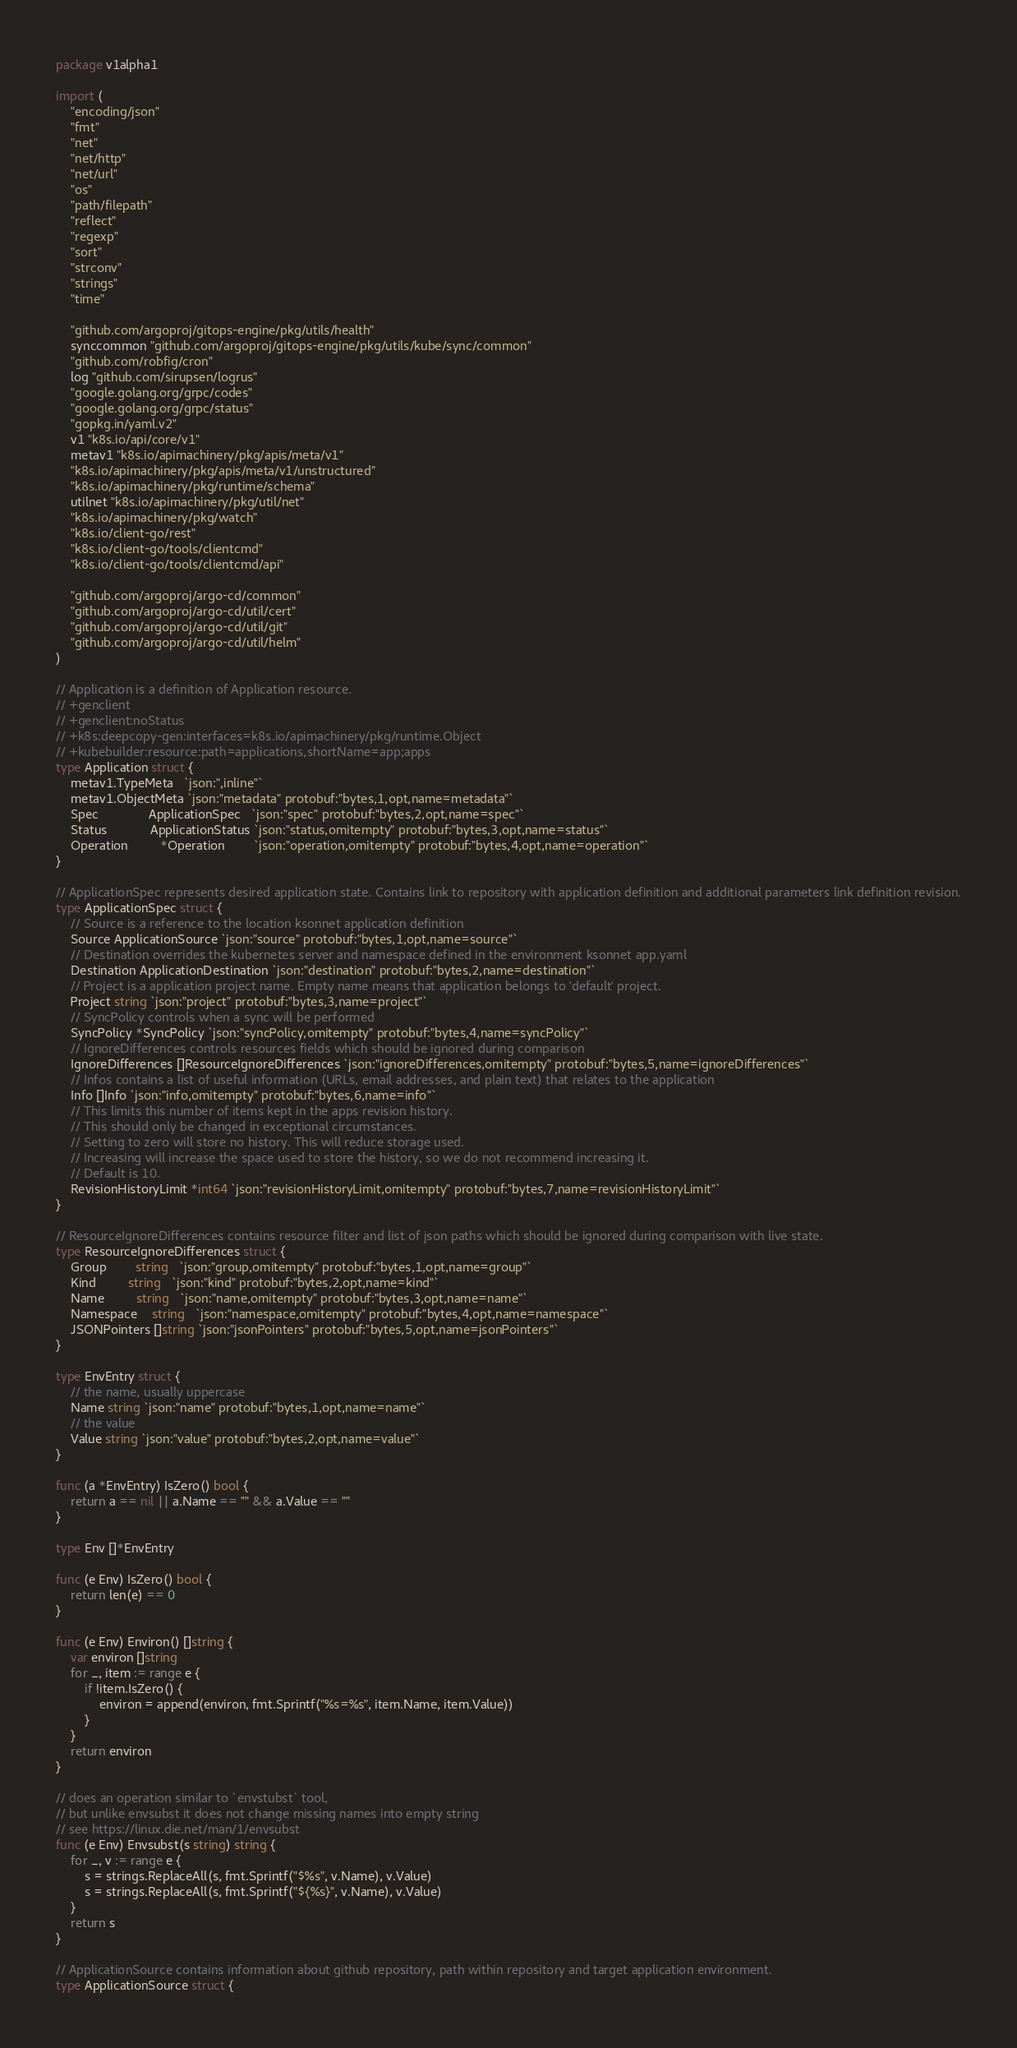<code> <loc_0><loc_0><loc_500><loc_500><_Go_>package v1alpha1

import (
	"encoding/json"
	"fmt"
	"net"
	"net/http"
	"net/url"
	"os"
	"path/filepath"
	"reflect"
	"regexp"
	"sort"
	"strconv"
	"strings"
	"time"

	"github.com/argoproj/gitops-engine/pkg/utils/health"
	synccommon "github.com/argoproj/gitops-engine/pkg/utils/kube/sync/common"
	"github.com/robfig/cron"
	log "github.com/sirupsen/logrus"
	"google.golang.org/grpc/codes"
	"google.golang.org/grpc/status"
	"gopkg.in/yaml.v2"
	v1 "k8s.io/api/core/v1"
	metav1 "k8s.io/apimachinery/pkg/apis/meta/v1"
	"k8s.io/apimachinery/pkg/apis/meta/v1/unstructured"
	"k8s.io/apimachinery/pkg/runtime/schema"
	utilnet "k8s.io/apimachinery/pkg/util/net"
	"k8s.io/apimachinery/pkg/watch"
	"k8s.io/client-go/rest"
	"k8s.io/client-go/tools/clientcmd"
	"k8s.io/client-go/tools/clientcmd/api"

	"github.com/argoproj/argo-cd/common"
	"github.com/argoproj/argo-cd/util/cert"
	"github.com/argoproj/argo-cd/util/git"
	"github.com/argoproj/argo-cd/util/helm"
)

// Application is a definition of Application resource.
// +genclient
// +genclient:noStatus
// +k8s:deepcopy-gen:interfaces=k8s.io/apimachinery/pkg/runtime.Object
// +kubebuilder:resource:path=applications,shortName=app;apps
type Application struct {
	metav1.TypeMeta   `json:",inline"`
	metav1.ObjectMeta `json:"metadata" protobuf:"bytes,1,opt,name=metadata"`
	Spec              ApplicationSpec   `json:"spec" protobuf:"bytes,2,opt,name=spec"`
	Status            ApplicationStatus `json:"status,omitempty" protobuf:"bytes,3,opt,name=status"`
	Operation         *Operation        `json:"operation,omitempty" protobuf:"bytes,4,opt,name=operation"`
}

// ApplicationSpec represents desired application state. Contains link to repository with application definition and additional parameters link definition revision.
type ApplicationSpec struct {
	// Source is a reference to the location ksonnet application definition
	Source ApplicationSource `json:"source" protobuf:"bytes,1,opt,name=source"`
	// Destination overrides the kubernetes server and namespace defined in the environment ksonnet app.yaml
	Destination ApplicationDestination `json:"destination" protobuf:"bytes,2,name=destination"`
	// Project is a application project name. Empty name means that application belongs to 'default' project.
	Project string `json:"project" protobuf:"bytes,3,name=project"`
	// SyncPolicy controls when a sync will be performed
	SyncPolicy *SyncPolicy `json:"syncPolicy,omitempty" protobuf:"bytes,4,name=syncPolicy"`
	// IgnoreDifferences controls resources fields which should be ignored during comparison
	IgnoreDifferences []ResourceIgnoreDifferences `json:"ignoreDifferences,omitempty" protobuf:"bytes,5,name=ignoreDifferences"`
	// Infos contains a list of useful information (URLs, email addresses, and plain text) that relates to the application
	Info []Info `json:"info,omitempty" protobuf:"bytes,6,name=info"`
	// This limits this number of items kept in the apps revision history.
	// This should only be changed in exceptional circumstances.
	// Setting to zero will store no history. This will reduce storage used.
	// Increasing will increase the space used to store the history, so we do not recommend increasing it.
	// Default is 10.
	RevisionHistoryLimit *int64 `json:"revisionHistoryLimit,omitempty" protobuf:"bytes,7,name=revisionHistoryLimit"`
}

// ResourceIgnoreDifferences contains resource filter and list of json paths which should be ignored during comparison with live state.
type ResourceIgnoreDifferences struct {
	Group        string   `json:"group,omitempty" protobuf:"bytes,1,opt,name=group"`
	Kind         string   `json:"kind" protobuf:"bytes,2,opt,name=kind"`
	Name         string   `json:"name,omitempty" protobuf:"bytes,3,opt,name=name"`
	Namespace    string   `json:"namespace,omitempty" protobuf:"bytes,4,opt,name=namespace"`
	JSONPointers []string `json:"jsonPointers" protobuf:"bytes,5,opt,name=jsonPointers"`
}

type EnvEntry struct {
	// the name, usually uppercase
	Name string `json:"name" protobuf:"bytes,1,opt,name=name"`
	// the value
	Value string `json:"value" protobuf:"bytes,2,opt,name=value"`
}

func (a *EnvEntry) IsZero() bool {
	return a == nil || a.Name == "" && a.Value == ""
}

type Env []*EnvEntry

func (e Env) IsZero() bool {
	return len(e) == 0
}

func (e Env) Environ() []string {
	var environ []string
	for _, item := range e {
		if !item.IsZero() {
			environ = append(environ, fmt.Sprintf("%s=%s", item.Name, item.Value))
		}
	}
	return environ
}

// does an operation similar to `envstubst` tool,
// but unlike envsubst it does not change missing names into empty string
// see https://linux.die.net/man/1/envsubst
func (e Env) Envsubst(s string) string {
	for _, v := range e {
		s = strings.ReplaceAll(s, fmt.Sprintf("$%s", v.Name), v.Value)
		s = strings.ReplaceAll(s, fmt.Sprintf("${%s}", v.Name), v.Value)
	}
	return s
}

// ApplicationSource contains information about github repository, path within repository and target application environment.
type ApplicationSource struct {</code> 